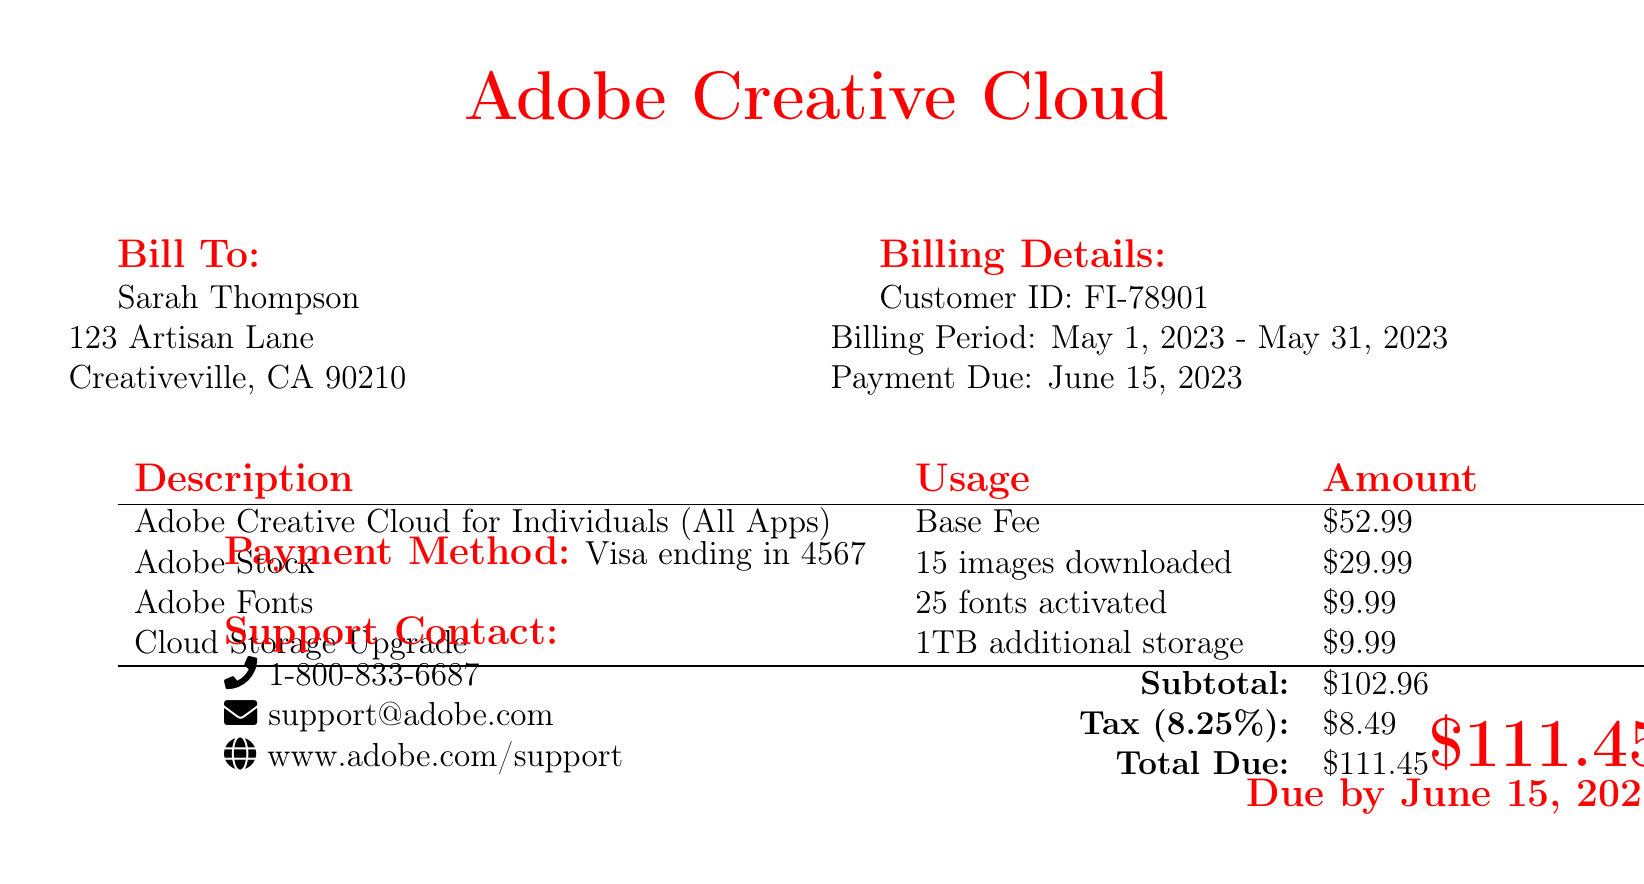what is the billing period? The billing period is the duration for which the charges are applicable, which is stated in the document as May 1, 2023 - May 31, 2023.
Answer: May 1, 2023 - May 31, 2023 what is the customer ID? The customer ID is a unique identifier for the billing account, specified in the document as FI-78901.
Answer: FI-78901 what is the subtotal amount? The subtotal amount is the sum of all line item charges before tax, listed as $102.96 in the document.
Answer: $102.96 how many images were downloaded from Adobe Stock? This number indicates how many images were downloaded during the billing period, noted as 15 images in the document.
Answer: 15 images when is the payment due? The payment due date indicates when the total payment should be completed, which is June 15, 2023, as mentioned in the document.
Answer: June 15, 2023 what is the total due? The total due is the final amount that must be paid, which includes tax, and is given as $111.45 in the document.
Answer: $111.45 what payment method is used? The payment method specifies how the payment will be made, detailed in the document as Visa ending in 4567.
Answer: Visa ending in 4567 how many fonts were activated through Adobe Fonts? This refers to the number of fonts activated during the subscription period, which is stated as 25 fonts in the document.
Answer: 25 fonts what is the tax rate applied to the bill? The tax rate indicates the percentage added to the subtotal, which is listed as 8.25% in the document.
Answer: 8.25% 